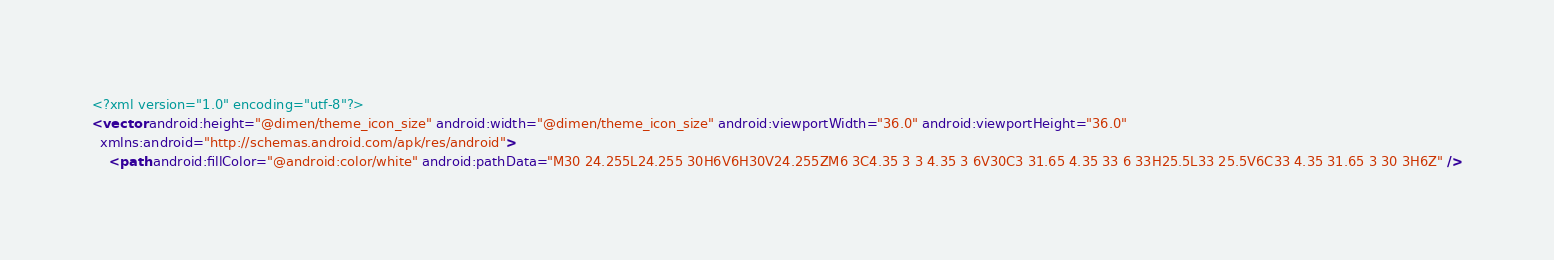<code> <loc_0><loc_0><loc_500><loc_500><_XML_><?xml version="1.0" encoding="utf-8"?>
<vector android:height="@dimen/theme_icon_size" android:width="@dimen/theme_icon_size" android:viewportWidth="36.0" android:viewportHeight="36.0"
  xmlns:android="http://schemas.android.com/apk/res/android">
    <path android:fillColor="@android:color/white" android:pathData="M30 24.255L24.255 30H6V6H30V24.255ZM6 3C4.35 3 3 4.35 3 6V30C3 31.65 4.35 33 6 33H25.5L33 25.5V6C33 4.35 31.65 3 30 3H6Z" /></code> 